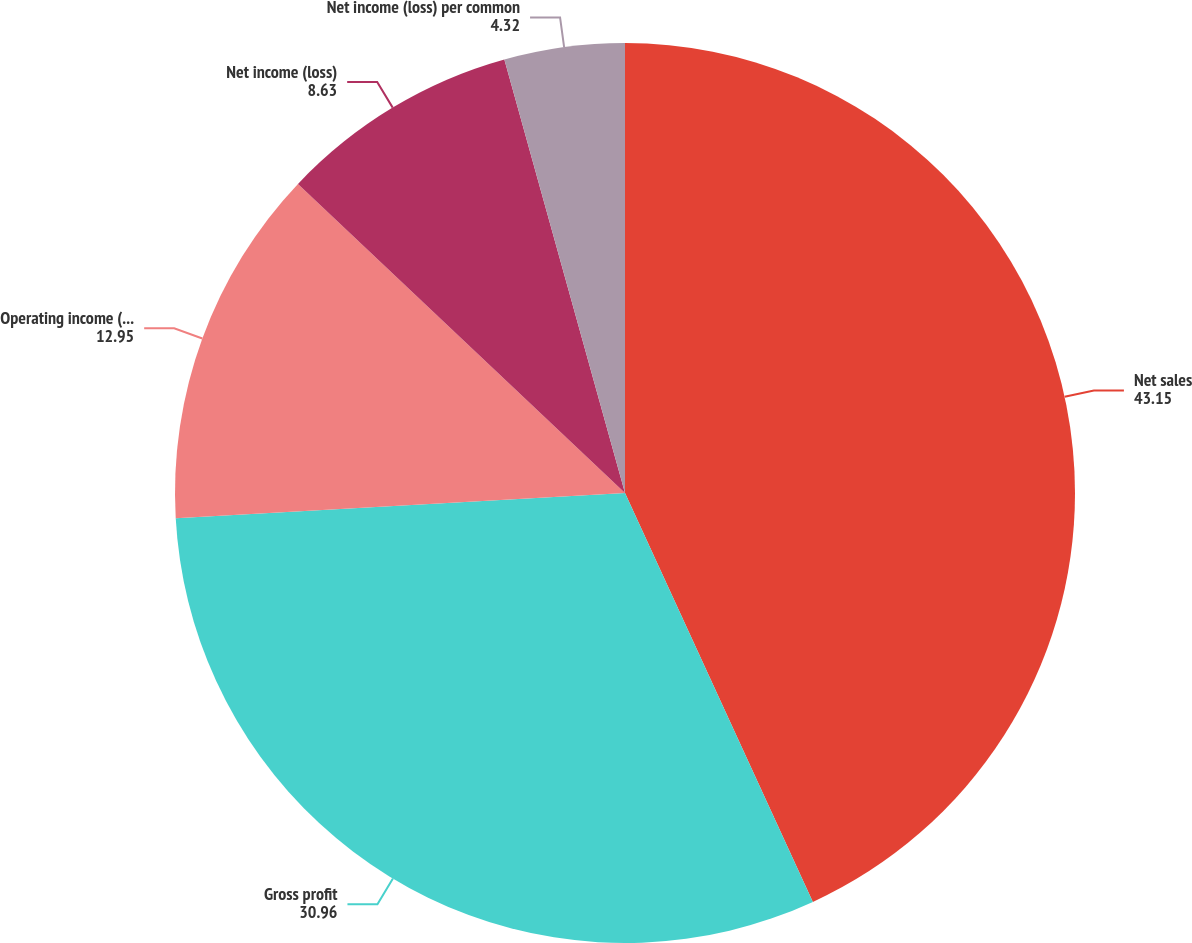<chart> <loc_0><loc_0><loc_500><loc_500><pie_chart><fcel>Net sales<fcel>Gross profit<fcel>Operating income (loss)<fcel>Net income (loss)<fcel>Net income (loss) per common<nl><fcel>43.15%<fcel>30.96%<fcel>12.95%<fcel>8.63%<fcel>4.32%<nl></chart> 